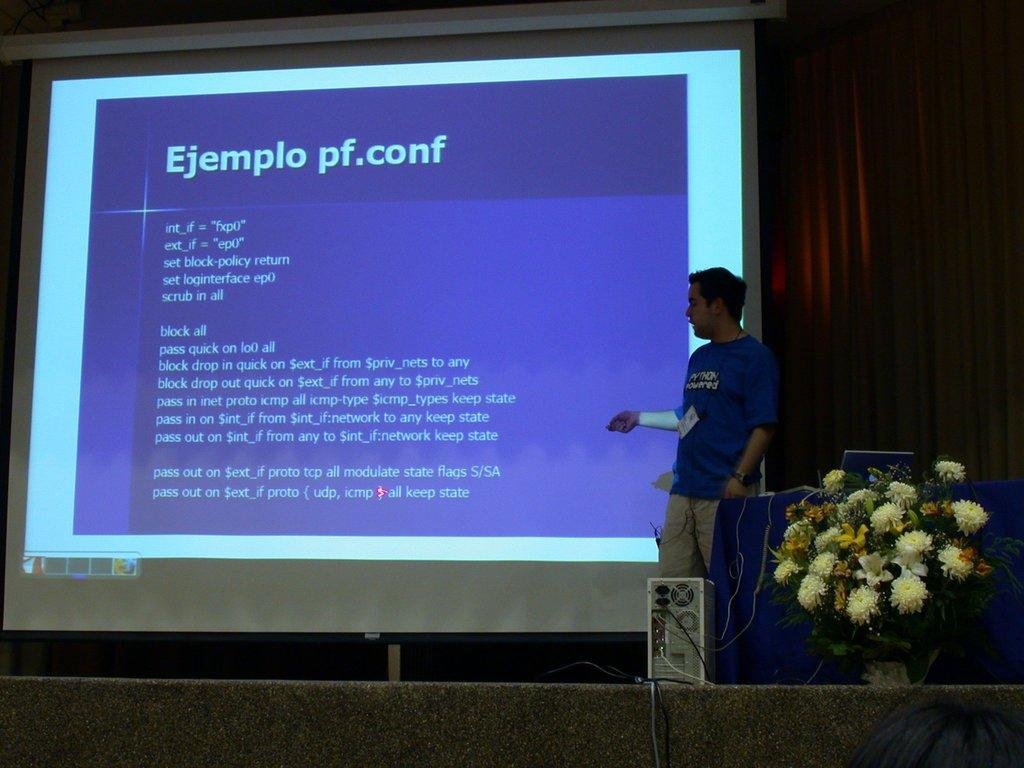Who is present on the right side of the image? There is a man standing on the right side of the image. What can be seen besides the man in the image? There is a flower bouquet, a CPU, a projector screen, and a curtain in the image. What might be used for displaying visuals in the image? There is a projector screen in the image. What type of fabric is present in the image? There is a curtain in the image, which is made of fabric. How many beds are visible in the image? There are no beds present in the image. Can you tell me the color of the worm in the image? There is no worm present in the image. 